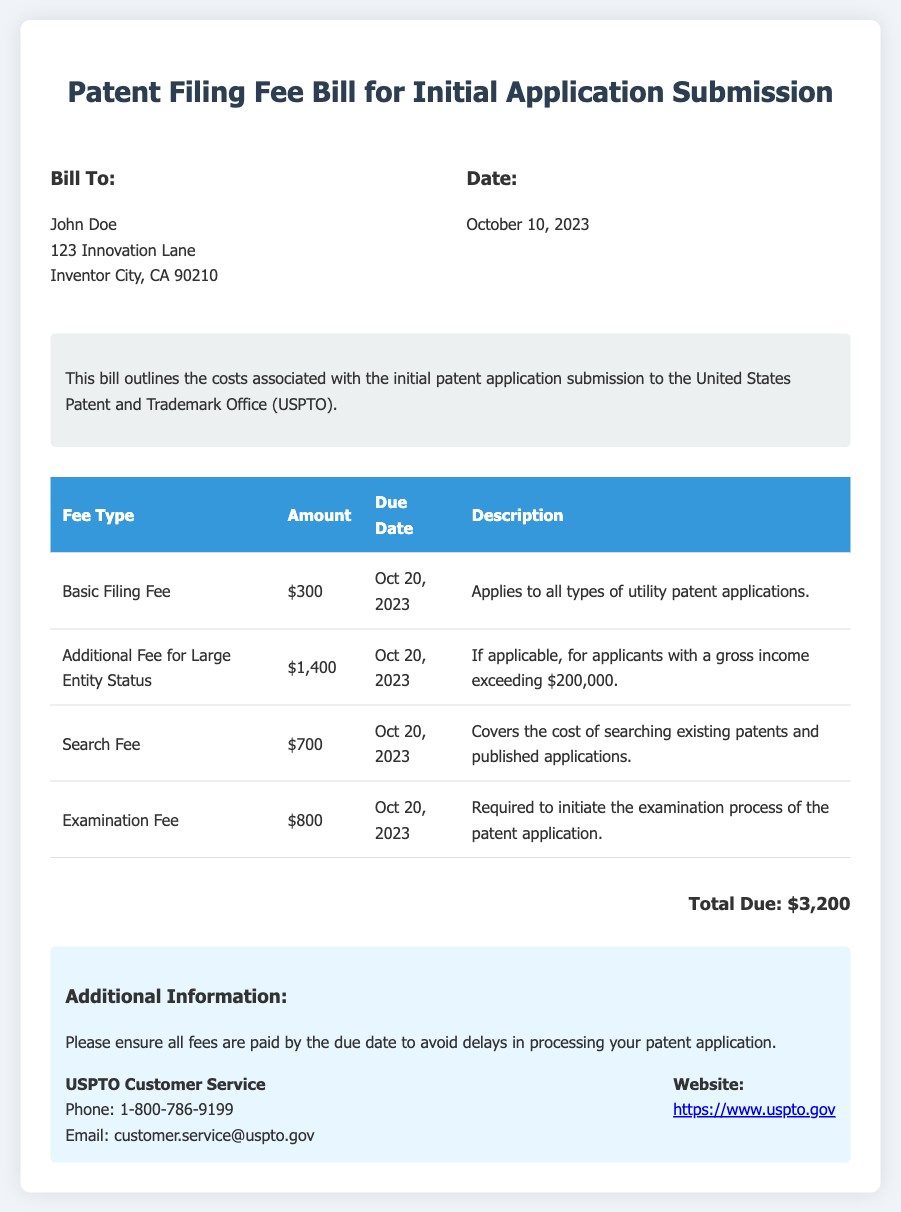What is the total due amount for the patent filing? The total due amount is provided at the bottom of the bill, which sums up all the fees listed.
Answer: $3,200 When is the due date for the basic filing fee? The due date for the basic filing fee is specified in the fee table under the due date column.
Answer: Oct 20, 2023 What is the additional fee for large entity status? The fee amount for large entity status is provided in the fee table, under the amount column.
Answer: $1,400 What does the examination fee cover? The bill provides a brief description of what the examination fee is for, listed in the description column.
Answer: Required to initiate the examination process of the patent application What is the purpose of the search fee? The purpose of the search fee is described in the documentation as covering a specific cost.
Answer: Covers the cost of searching existing patents and published applications What is the contact phone number for USPTO customer service? The document includes a section for contact information, including the phone number.
Answer: 1-800-786-9199 What date was the bill issued? The issued date is clearly noted in the bill information section of the document.
Answer: October 10, 2023 What is included in the total due amount? The total due amount includes a combination of all the fees listed in the table.
Answer: $3,200 